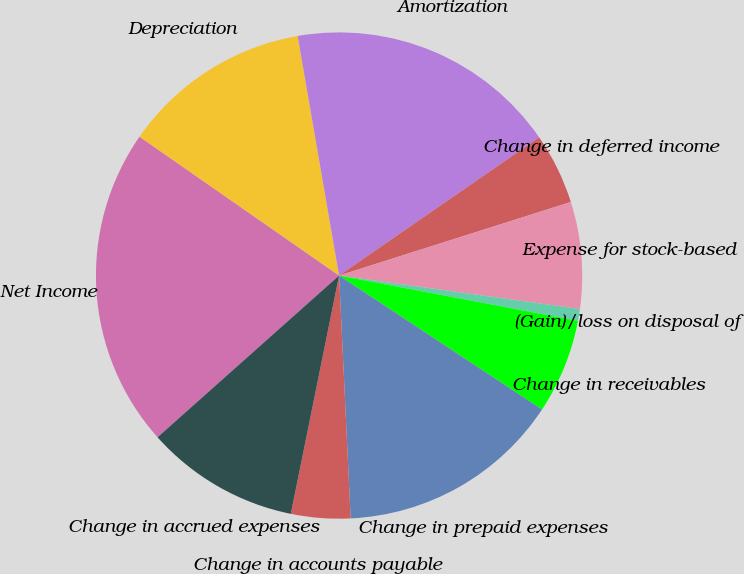Convert chart to OTSL. <chart><loc_0><loc_0><loc_500><loc_500><pie_chart><fcel>Net Income<fcel>Depreciation<fcel>Amortization<fcel>Change in deferred income<fcel>Expense for stock-based<fcel>(Gain)/loss on disposal of<fcel>Change in receivables<fcel>Change in prepaid expenses<fcel>Change in accounts payable<fcel>Change in accrued expenses<nl><fcel>21.26%<fcel>12.6%<fcel>18.11%<fcel>4.73%<fcel>7.09%<fcel>0.79%<fcel>6.3%<fcel>14.96%<fcel>3.94%<fcel>10.24%<nl></chart> 